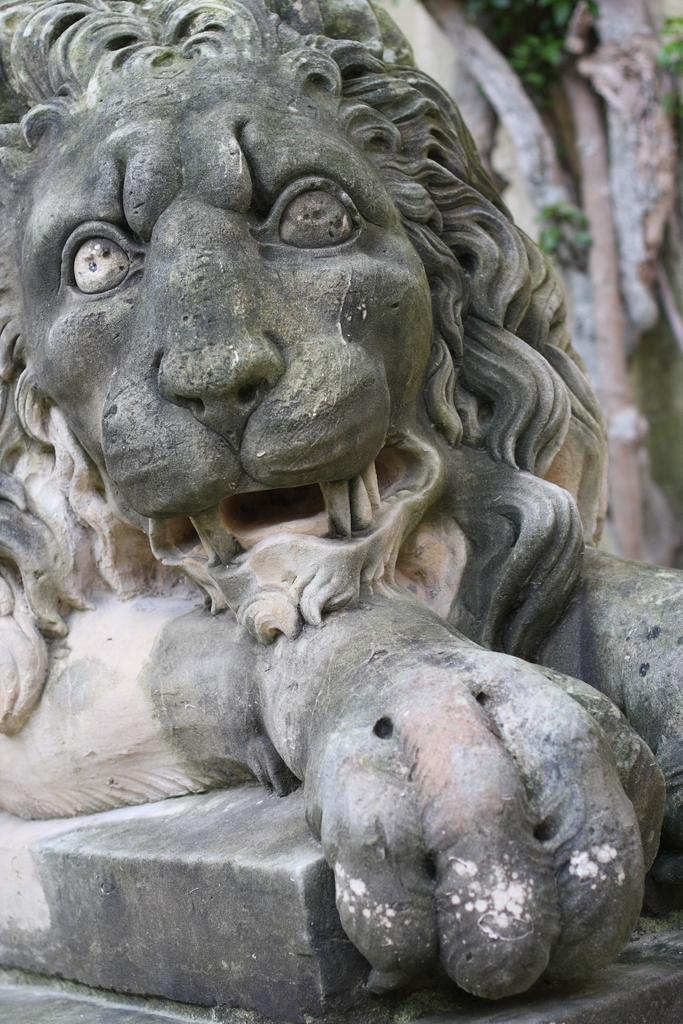What is the main subject of the image? There is a sculpture of a lion in the image. Can you describe the background on the right side of the image? The right side background is blurry. What type of vegetation can be seen in the image? There are plants visible in the image. What other object can be seen in the image besides the lion sculpture and plants? There is a pole in the image. What type of oatmeal is being served to the babies in the image? There are no babies or oatmeal present in the image; it features a lion sculpture, plants, and a pole. 